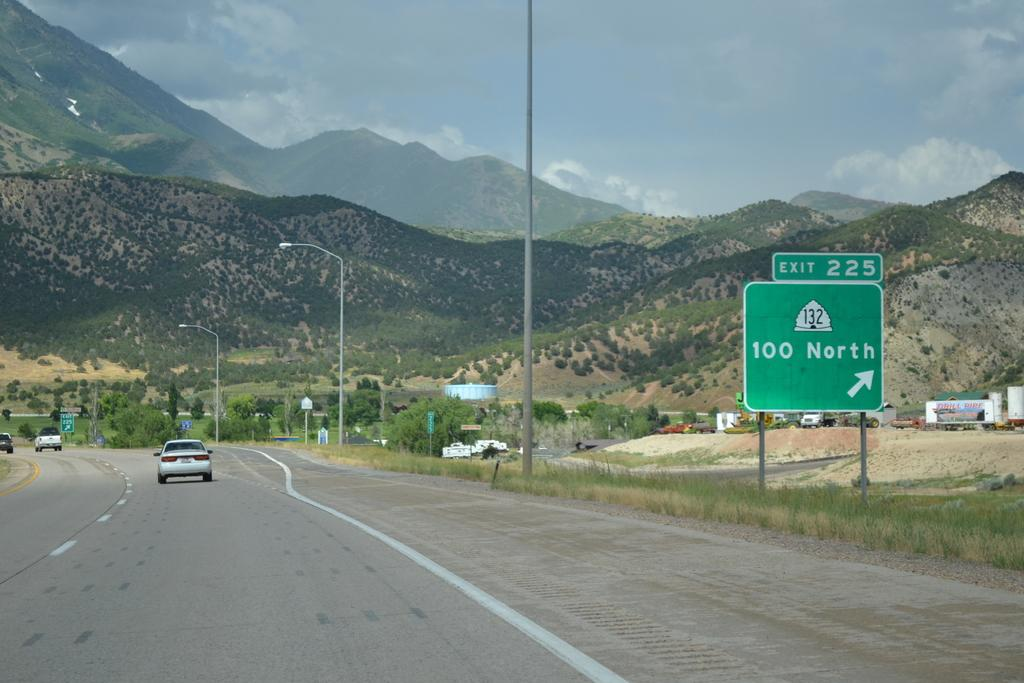What type of landscape can be seen in the image? There are hills in the image, which suggests a hilly landscape. What type of vegetation is present in the image? There are trees in the image, indicating the presence of vegetation. What type of man-made structures can be seen in the image? There are sign boards and light poles in the image, which are man-made structures. What is happening on the road in the image? Vehicles are passing on the road in the image, indicating traffic or movement. What is visible in the sky in the image? There is sky with clouds visible in the image, suggesting the presence of clouds. What type of ground cover is present in the image? Grass is visible in the image, which is a type of ground cover. How many horses can be seen grazing in the grass in the image? There are no horses present in the image; it only shows hills, trees, sign boards, light poles, vehicles, sky, and grass. What is the coefficient of friction between the tires of the vehicles and the road in the image? The image does not provide information about the coefficient of friction between the tires of the vehicles and the road. 